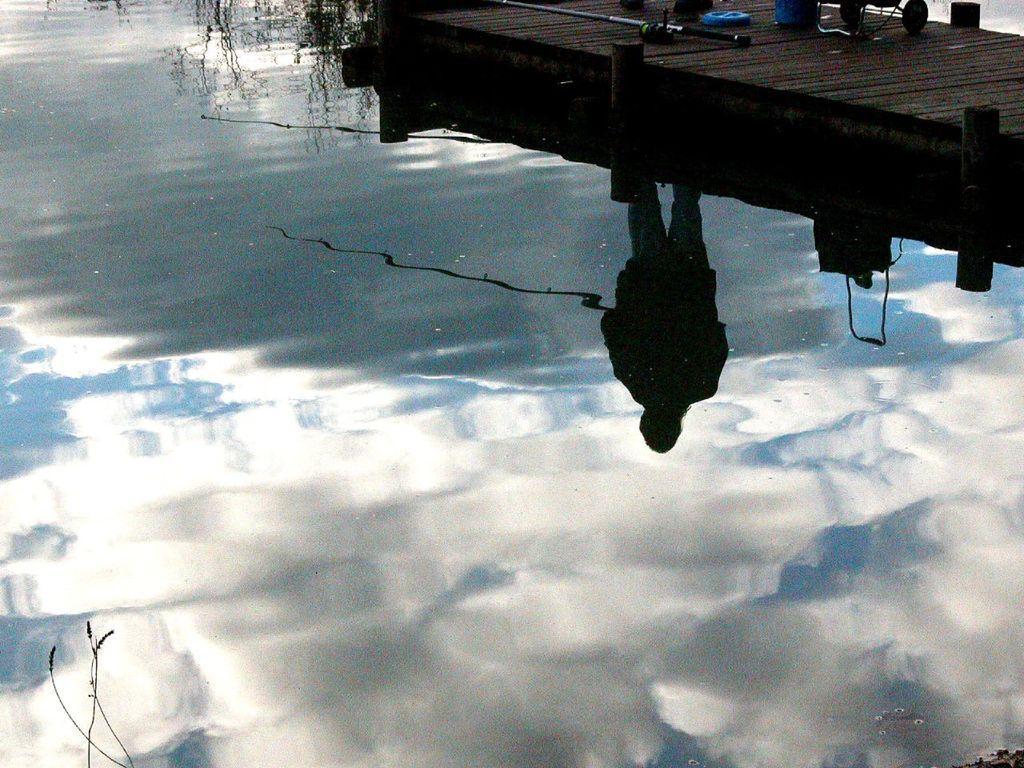Could you give a brief overview of what you see in this image? In the foreground of the picture there is a water body. At the top we can see a dock, on the dock there are fishing needle, wheels of a vehicle, person´s legs and other objects. 